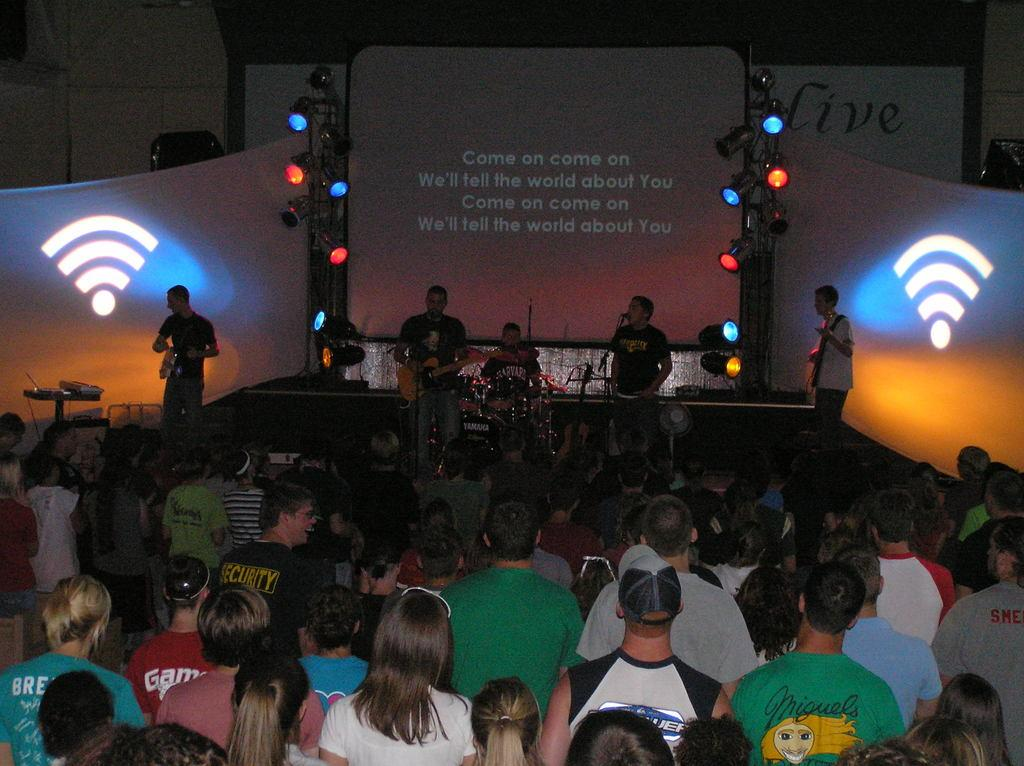What are the persons at the top of the image doing? The persons at the top of the image are standing on a dais and holding musical instruments in their hands. What are the persons at the bottom of the image doing? The persons at the bottom of the image are standing on the floor. What type of silver is being used to create a stamp on the jelly in the image? There is no silver, stamp, or jelly present in the image. 